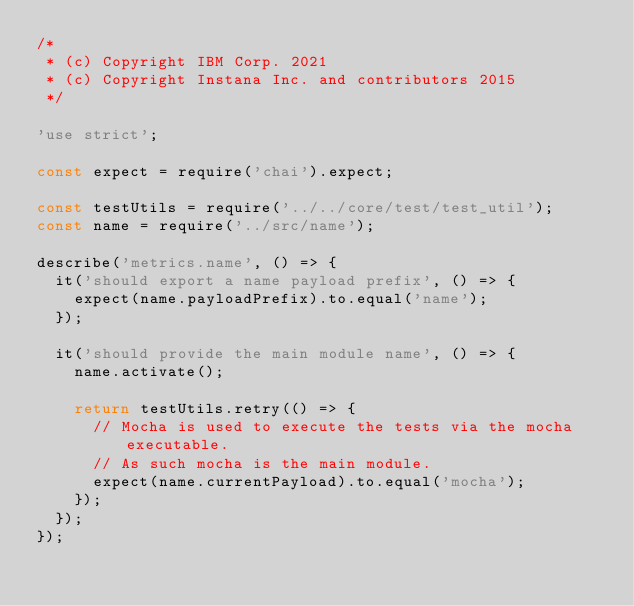Convert code to text. <code><loc_0><loc_0><loc_500><loc_500><_JavaScript_>/*
 * (c) Copyright IBM Corp. 2021
 * (c) Copyright Instana Inc. and contributors 2015
 */

'use strict';

const expect = require('chai').expect;

const testUtils = require('../../core/test/test_util');
const name = require('../src/name');

describe('metrics.name', () => {
  it('should export a name payload prefix', () => {
    expect(name.payloadPrefix).to.equal('name');
  });

  it('should provide the main module name', () => {
    name.activate();

    return testUtils.retry(() => {
      // Mocha is used to execute the tests via the mocha executable.
      // As such mocha is the main module.
      expect(name.currentPayload).to.equal('mocha');
    });
  });
});
</code> 